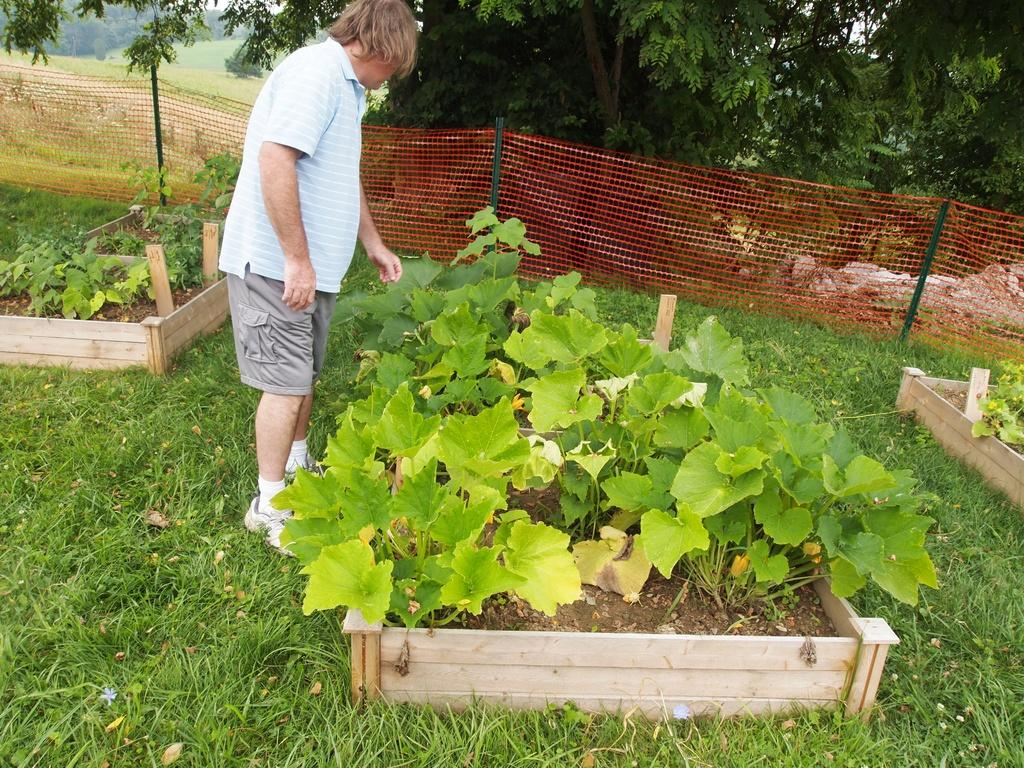What is the man doing in the garden? The man is checking cultivated plants in the garden. How are the plants arranged or contained? The plants are kept inside a wooden box. What type of barrier surrounds the garden? There is a red color net fencing around the garden. What can be seen in the background of the image? Trees are visible in the background. What type of alarm can be heard going off in the garden? There is no alarm present or audible in the image. What error is the man trying to fix in the garden? The image does not indicate any errors or problems that the man is trying to fix. 